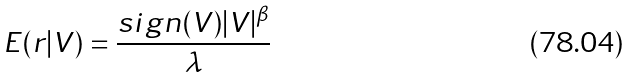<formula> <loc_0><loc_0><loc_500><loc_500>E ( r | V ) = \frac { s i g n ( V ) | V | ^ { \beta } } { \lambda }</formula> 